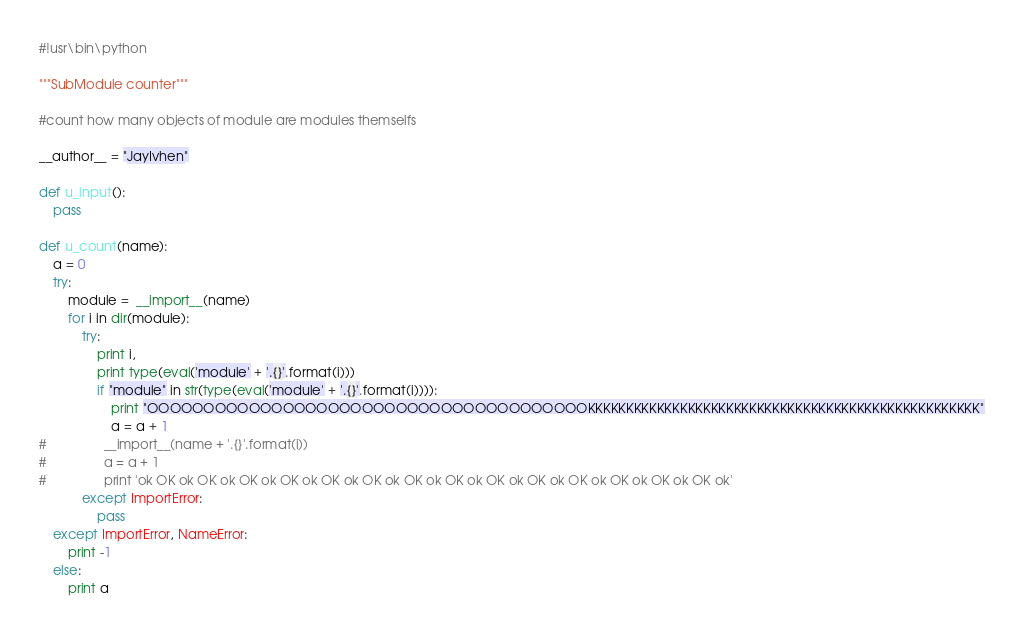<code> <loc_0><loc_0><loc_500><loc_500><_Python_>#!usr\bin\python

"""SubModule counter"""

#count how many objects of module are modules themselfs

__author__ = "JayIvhen"

def u_input():
    pass

def u_count(name):
    a = 0
    try:
        module =  __import__(name)
        for i in dir(module):
            try:
                print i,
                print type(eval('module' + '.{}'.format(i)))
                if "module" in str(type(eval('module' + '.{}'.format(i)))):
                    print "OOOOOOOOOOOOOOOOOOOOOOOOOOOOOOOOOOOOOOOKKKKKKKKKKKKKKKKKKKKKKKKKKKKKKKKKKKKKKKKKKKKKKKKKKK"
                    a = a + 1
#                __import__(name + '.{}'.format(i))
#                a = a + 1
#                print 'ok OK ok OK ok OK ok OK ok OK ok OK ok OK ok OK ok OK ok OK ok OK ok OK ok OK ok OK ok'
            except ImportError:
                pass
    except ImportError, NameError:
        print -1
    else:
        print a
</code> 